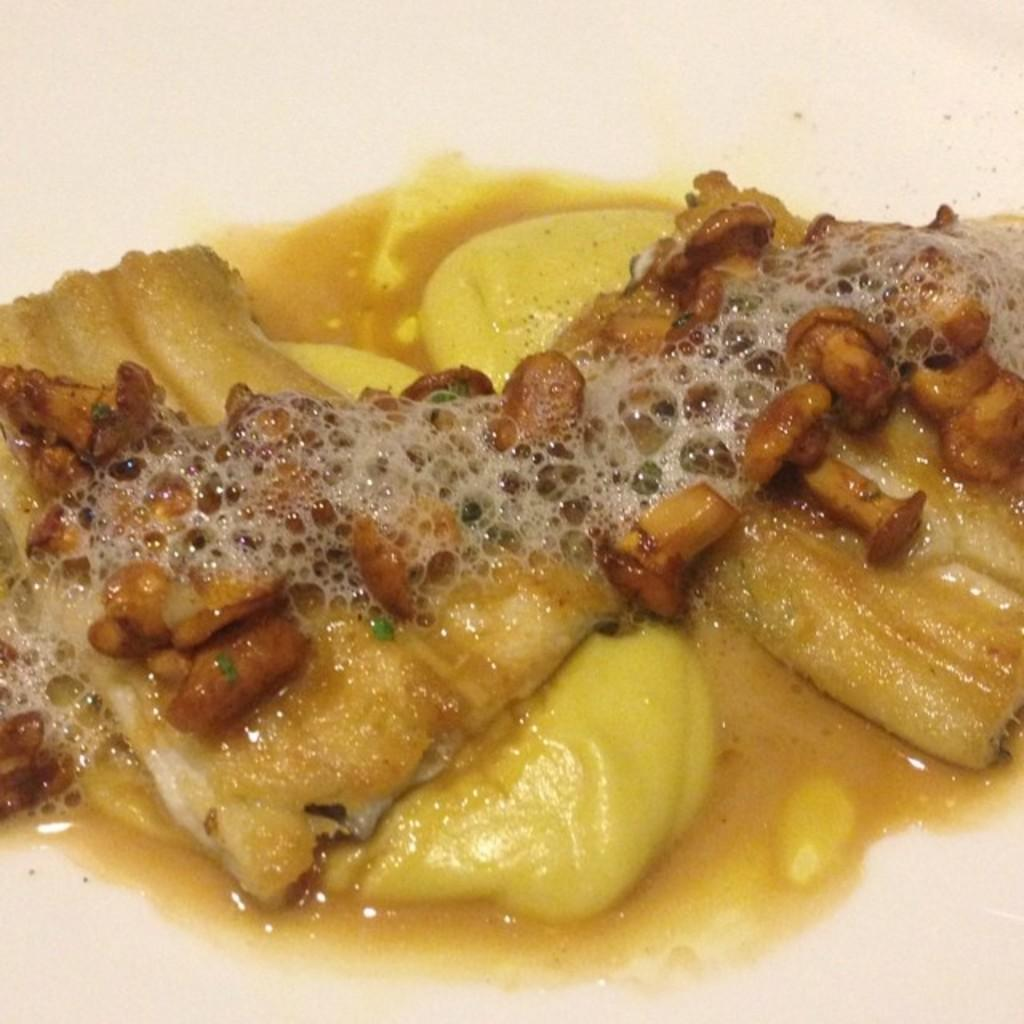What is the main subject of the image? There is a food item in the image. Can you describe the food item in more detail? The food item has some liquid in it. What type of substance is being used to create the curve in the image? There is no curve present in the image, and therefore no substance is being used to create it. 